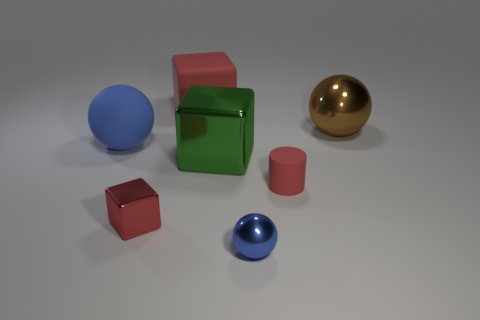Are there more large red objects in front of the big green thing than blue matte things right of the big brown shiny sphere?
Offer a terse response. No. There is another metallic thing that is the same size as the brown shiny thing; what is its color?
Give a very brief answer. Green. Is there another small shiny sphere of the same color as the tiny ball?
Your answer should be compact. No. Is the color of the big rubber sphere behind the big green metal block the same as the big thing that is right of the large metal block?
Ensure brevity in your answer.  No. What material is the big sphere on the left side of the red rubber cylinder?
Your answer should be compact. Rubber. There is a large block that is the same material as the tiny cylinder; what color is it?
Keep it short and to the point. Red. How many red shiny objects have the same size as the red cylinder?
Ensure brevity in your answer.  1. Do the red thing that is right of the green cube and the tiny blue metallic object have the same size?
Offer a very short reply. Yes. What is the shape of the red thing that is in front of the big green metal cube and left of the tiny sphere?
Provide a succinct answer. Cube. There is a big brown object; are there any blue metal objects behind it?
Your answer should be very brief. No. 